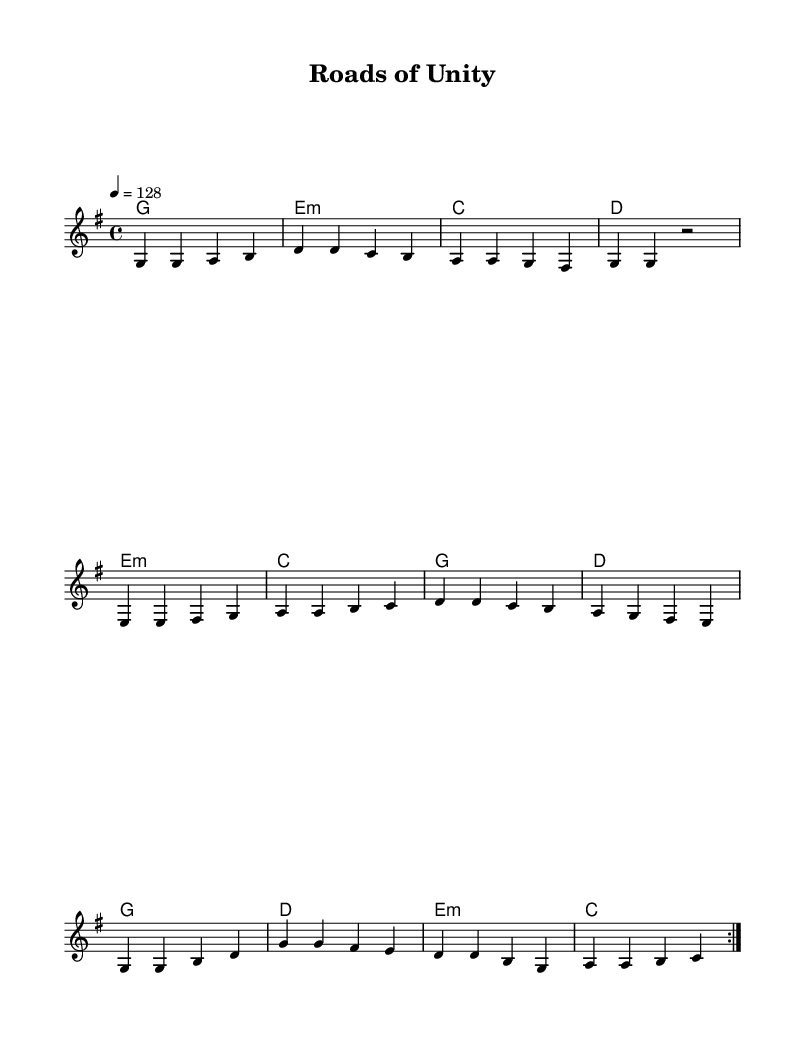What is the key signature of this music? The key signature is G major, which has one sharp (F#). We can determine this by looking at the key signature indicated at the beginning of the piece.
Answer: G major What is the time signature of this music? The time signature is 4/4, as indicated at the beginning of the score. It shows that there are four beats in each measure and the quarter note gets one beat.
Answer: 4/4 What is the tempo marking of this music? The tempo marking is 128 beats per minute, shown at the beginning of the piece. This indicates the speed at which the music should be played.
Answer: 128 How many measures are repeated in the melody section? The melody section has a repeat sign indicating two complete measures are repeated. This is seen where the repeat sign appears before the section starts anew.
Answer: 2 What type of harmony is indicated at the start of the piece? The harmony type at the start is G major, which is indicated in the chord names at the beginning of the score. This tells us the underlying chords that accompany the melody.
Answer: G major What rhythmic pattern is primarily used in the melody? The primary rhythmic pattern in the melody is mainly comprised of quarter notes, seen throughout the notes in the first section of the piece. This allows for a steady, upbeat, and danceable feel typical of dance-pop songs.
Answer: Quarter notes What is the significance of the repetition in dance music? The repetition found in this piece enhances engagement and helps create a memorable hook, which is typical in dance-pop songs. This is particularly important in dance music for energizing the listeners and encouraging movement.
Answer: Engaging repetition 